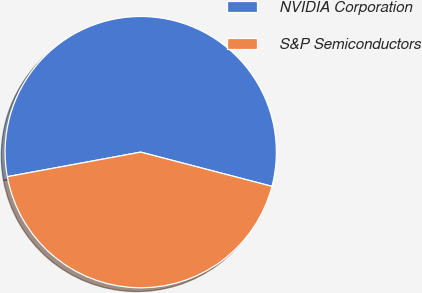Convert chart. <chart><loc_0><loc_0><loc_500><loc_500><pie_chart><fcel>NVIDIA Corporation<fcel>S&P Semiconductors<nl><fcel>56.96%<fcel>43.04%<nl></chart> 